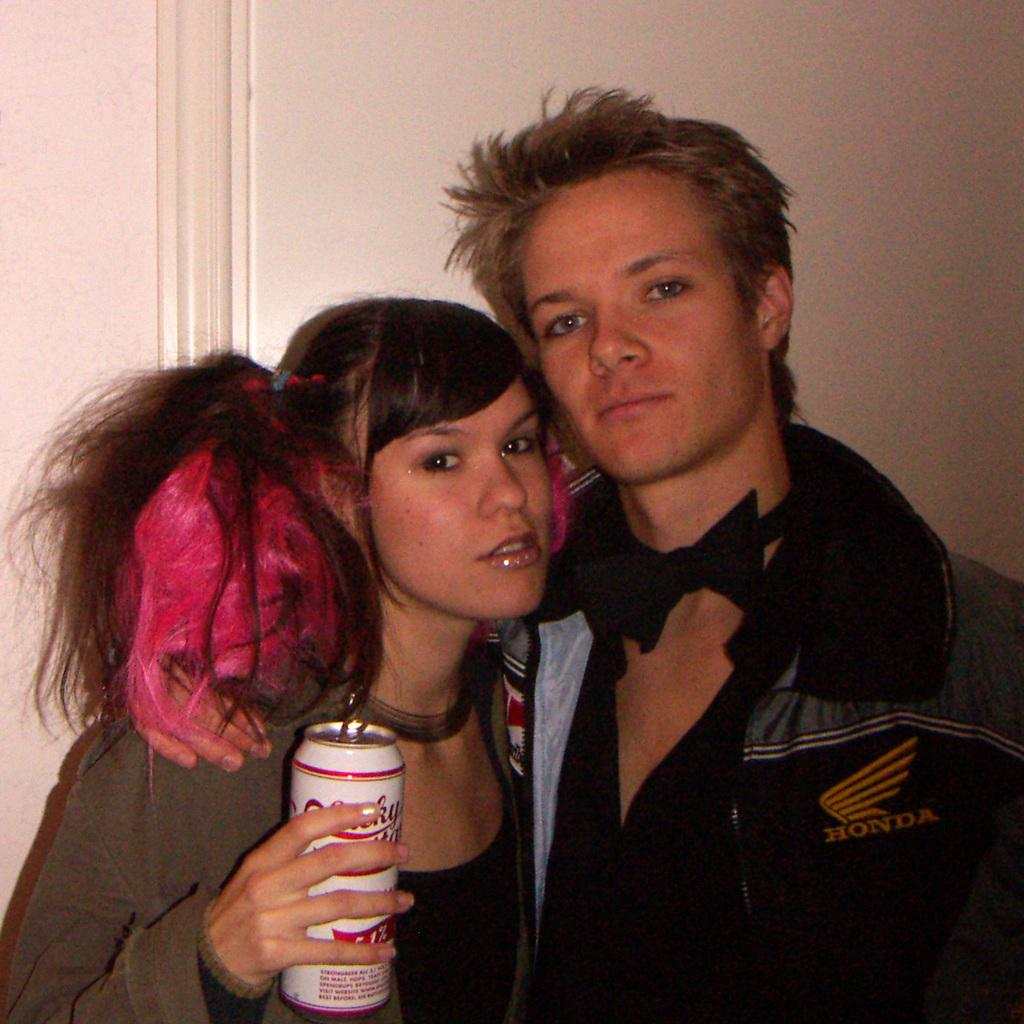Who are the people in the image? There is a man and a woman in the image. What is the woman holding in the image? The woman is holding a tin in the image. What can be seen in the background of the image? There is a wall in the background of the image. What type of haircut does the man have in the image? There is no information about the man's haircut in the image. Are the man and woman in the image related as parent and child? There is no information about their relationship in the image. 